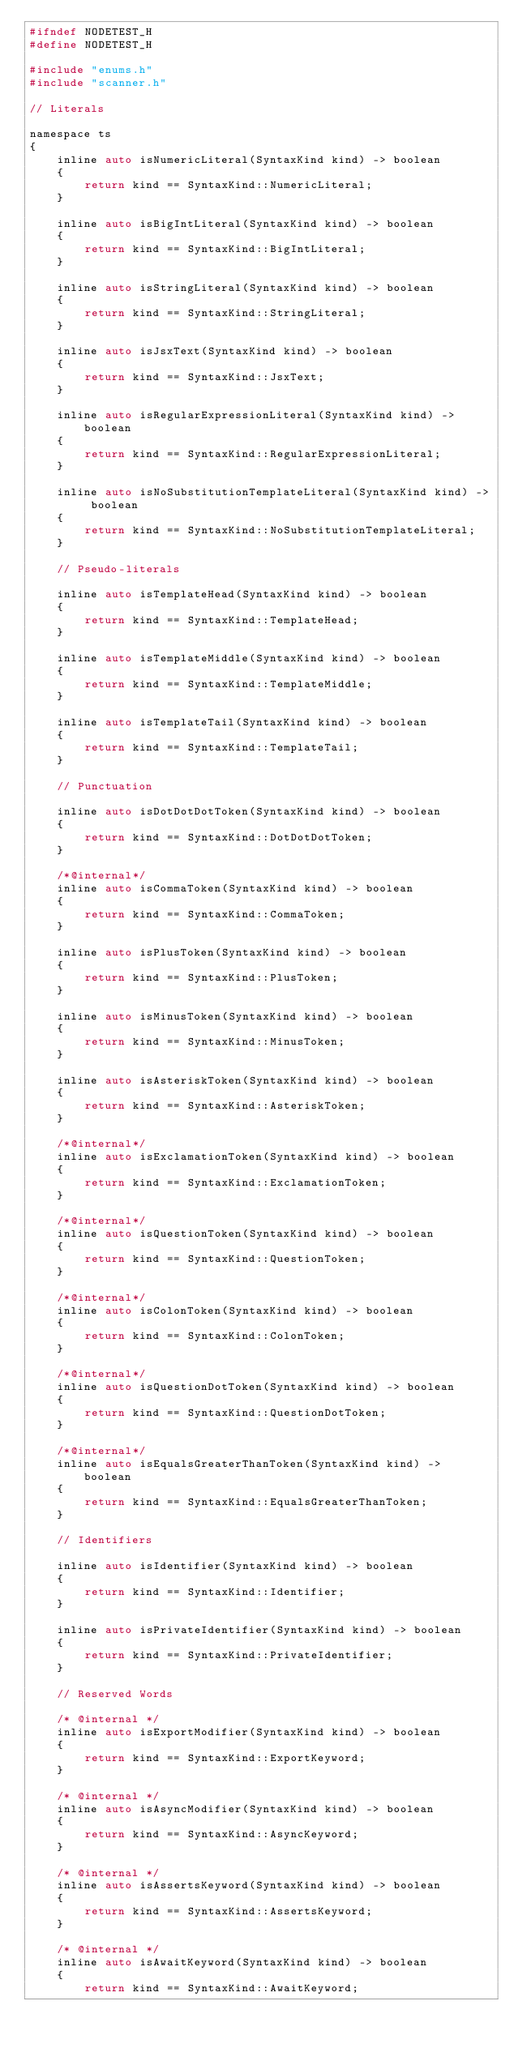<code> <loc_0><loc_0><loc_500><loc_500><_C_>#ifndef NODETEST_H
#define NODETEST_H

#include "enums.h"
#include "scanner.h"

// Literals

namespace ts
{
    inline auto isNumericLiteral(SyntaxKind kind) -> boolean
    {
        return kind == SyntaxKind::NumericLiteral;
    }

    inline auto isBigIntLiteral(SyntaxKind kind) -> boolean
    {
        return kind == SyntaxKind::BigIntLiteral;
    }

    inline auto isStringLiteral(SyntaxKind kind) -> boolean
    {
        return kind == SyntaxKind::StringLiteral;
    }

    inline auto isJsxText(SyntaxKind kind) -> boolean
    {
        return kind == SyntaxKind::JsxText;
    }

    inline auto isRegularExpressionLiteral(SyntaxKind kind) -> boolean
    {
        return kind == SyntaxKind::RegularExpressionLiteral;
    }

    inline auto isNoSubstitutionTemplateLiteral(SyntaxKind kind) -> boolean
    {
        return kind == SyntaxKind::NoSubstitutionTemplateLiteral;
    }

    // Pseudo-literals

    inline auto isTemplateHead(SyntaxKind kind) -> boolean
    {
        return kind == SyntaxKind::TemplateHead;
    }

    inline auto isTemplateMiddle(SyntaxKind kind) -> boolean
    {
        return kind == SyntaxKind::TemplateMiddle;
    }

    inline auto isTemplateTail(SyntaxKind kind) -> boolean
    {
        return kind == SyntaxKind::TemplateTail;
    }

    // Punctuation

    inline auto isDotDotDotToken(SyntaxKind kind) -> boolean
    {
        return kind == SyntaxKind::DotDotDotToken;
    }

    /*@internal*/
    inline auto isCommaToken(SyntaxKind kind) -> boolean
    {
        return kind == SyntaxKind::CommaToken;
    }

    inline auto isPlusToken(SyntaxKind kind) -> boolean
    {
        return kind == SyntaxKind::PlusToken;
    }

    inline auto isMinusToken(SyntaxKind kind) -> boolean
    {
        return kind == SyntaxKind::MinusToken;
    }

    inline auto isAsteriskToken(SyntaxKind kind) -> boolean
    {
        return kind == SyntaxKind::AsteriskToken;
    }

    /*@internal*/
    inline auto isExclamationToken(SyntaxKind kind) -> boolean
    {
        return kind == SyntaxKind::ExclamationToken;
    }

    /*@internal*/
    inline auto isQuestionToken(SyntaxKind kind) -> boolean
    {
        return kind == SyntaxKind::QuestionToken;
    }

    /*@internal*/
    inline auto isColonToken(SyntaxKind kind) -> boolean
    {
        return kind == SyntaxKind::ColonToken;
    }

    /*@internal*/
    inline auto isQuestionDotToken(SyntaxKind kind) -> boolean
    {
        return kind == SyntaxKind::QuestionDotToken;
    }

    /*@internal*/
    inline auto isEqualsGreaterThanToken(SyntaxKind kind) -> boolean
    {
        return kind == SyntaxKind::EqualsGreaterThanToken;
    }

    // Identifiers

    inline auto isIdentifier(SyntaxKind kind) -> boolean
    {
        return kind == SyntaxKind::Identifier;
    }

    inline auto isPrivateIdentifier(SyntaxKind kind) -> boolean
    {
        return kind == SyntaxKind::PrivateIdentifier;
    }

    // Reserved Words

    /* @internal */
    inline auto isExportModifier(SyntaxKind kind) -> boolean
    {
        return kind == SyntaxKind::ExportKeyword;
    }

    /* @internal */
    inline auto isAsyncModifier(SyntaxKind kind) -> boolean
    {
        return kind == SyntaxKind::AsyncKeyword;
    }

    /* @internal */
    inline auto isAssertsKeyword(SyntaxKind kind) -> boolean
    {
        return kind == SyntaxKind::AssertsKeyword;
    }

    /* @internal */
    inline auto isAwaitKeyword(SyntaxKind kind) -> boolean
    {
        return kind == SyntaxKind::AwaitKeyword;</code> 